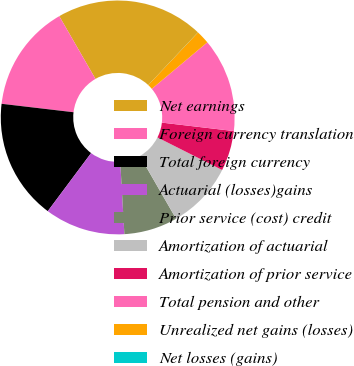Convert chart. <chart><loc_0><loc_0><loc_500><loc_500><pie_chart><fcel>Net earnings<fcel>Foreign currency translation<fcel>Total foreign currency<fcel>Actuarial (losses)gains<fcel>Prior service (cost) credit<fcel>Amortization of actuarial<fcel>Amortization of prior service<fcel>Total pension and other<fcel>Unrealized net gains (losses)<fcel>Net losses (gains)<nl><fcel>20.36%<fcel>14.81%<fcel>16.66%<fcel>11.11%<fcel>7.41%<fcel>9.26%<fcel>5.56%<fcel>12.96%<fcel>1.86%<fcel>0.01%<nl></chart> 